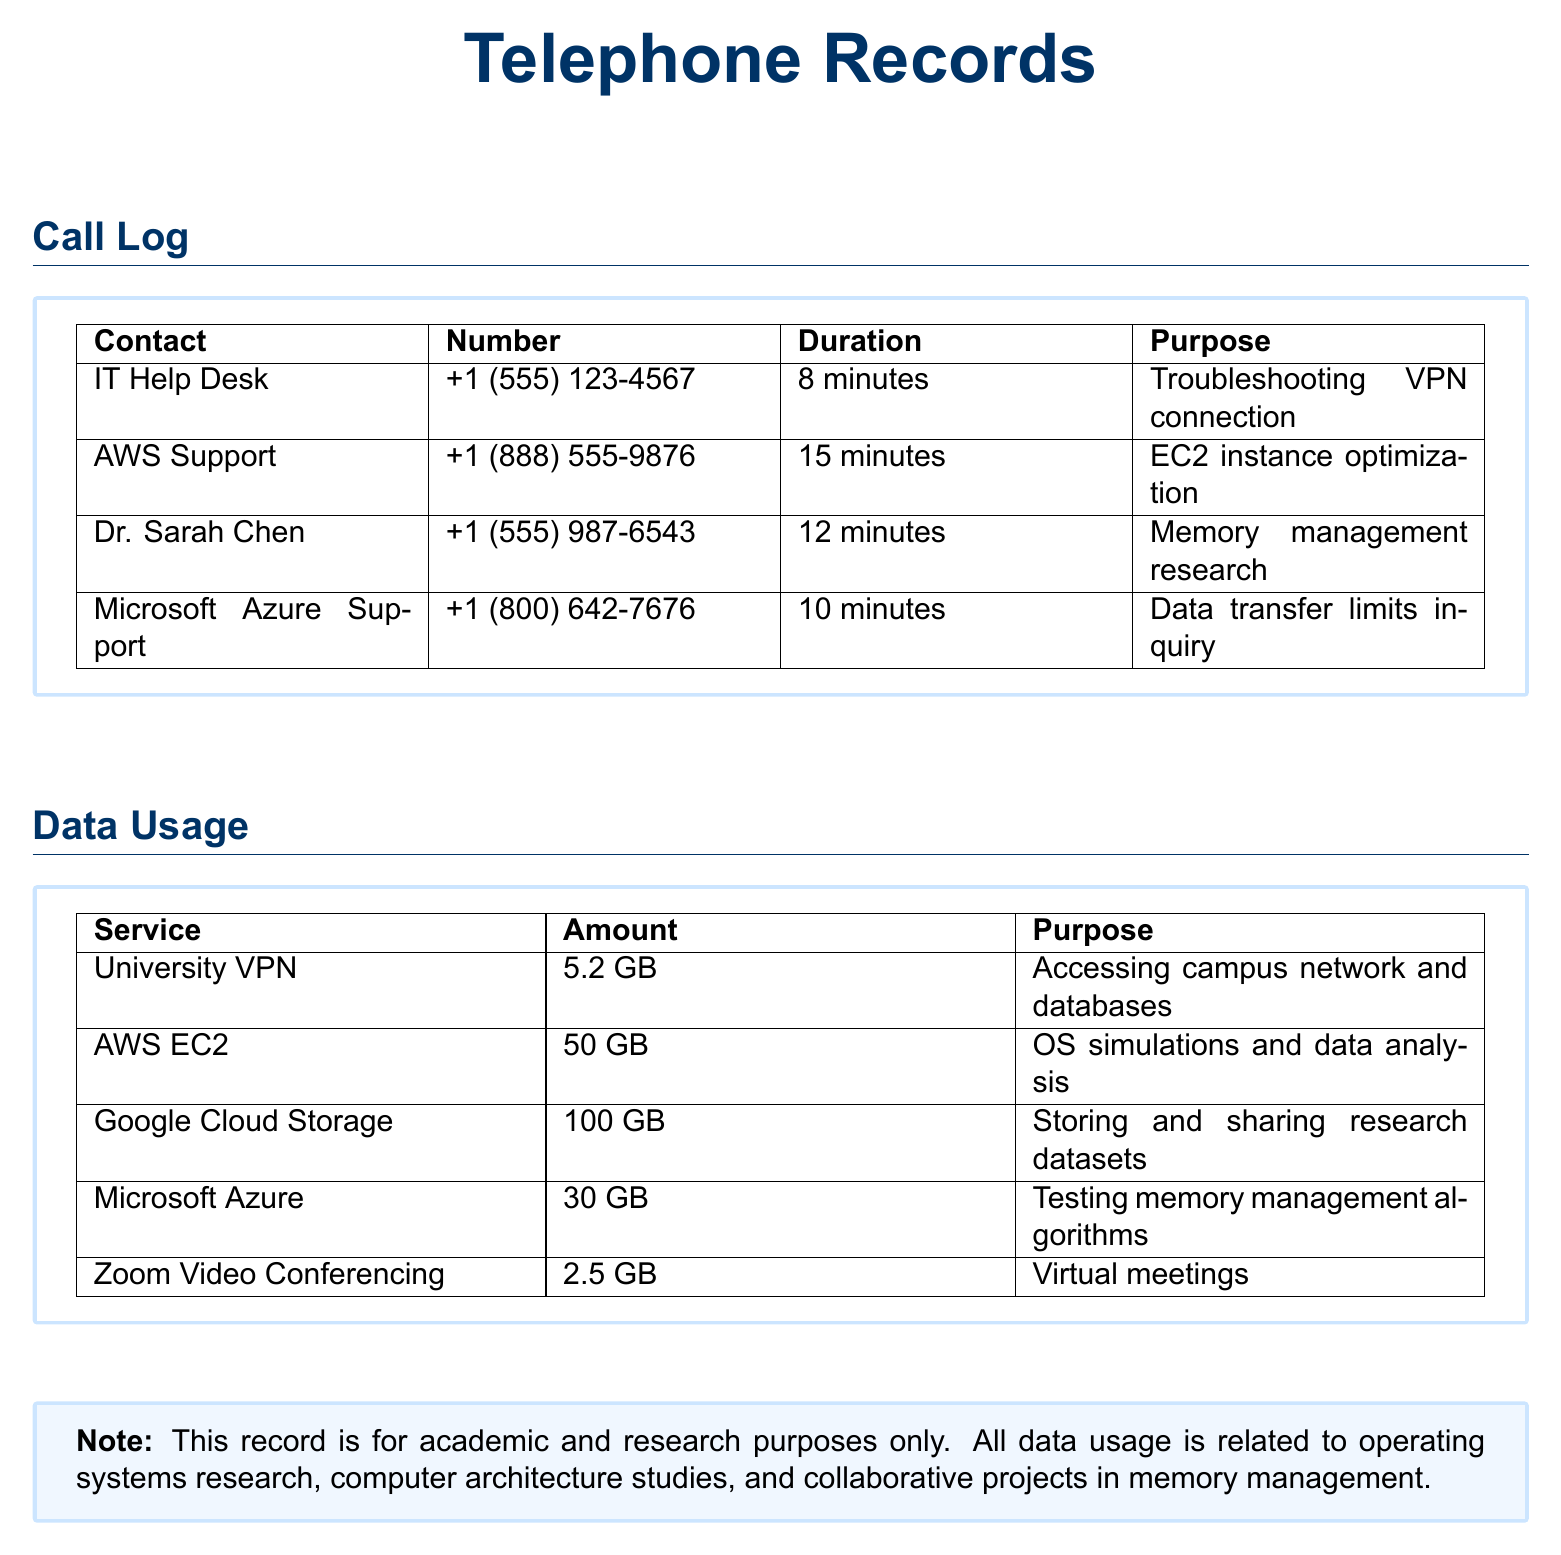What was the duration of the call to IT Help Desk? The call to IT Help Desk lasted for 8 minutes, as shown in the call log.
Answer: 8 minutes How much data was used for Google Cloud Storage? The data used for Google Cloud Storage is noted as 100 GB in the data usage section.
Answer: 100 GB What is the purpose of the call to AWS Support? The purpose of the call to AWS Support is EC2 instance optimization, as stated in the document.
Answer: EC2 instance optimization Which service used 30 GB of data? The service that used 30 GB of data is Microsoft Azure, according to the data usage table.
Answer: Microsoft Azure How long was the call to Dr. Sarah Chen? The call to Dr. Sarah Chen was 12 minutes long, as per the call log provided.
Answer: 12 minutes What is the total amount of data used among all listed services? The total data usage is calculated by adding all the amounts: 5.2 GB + 50 GB + 100 GB + 30 GB + 2.5 GB = 187.7 GB.
Answer: 187.7 GB What type of document is this? The document is a record of telephone calls and data usage for academic and research purposes.
Answer: Telephone records Why was Zoom Video Conferencing used? Zoom Video Conferencing was used for virtual meetings as stated in the data usage section.
Answer: Virtual meetings 